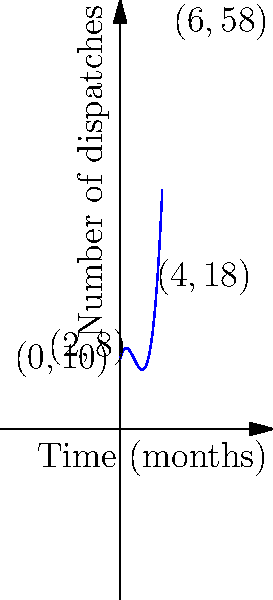The cubic polynomial graph represents the number of foreign correspondent dispatches during the first 6 months of the Spanish Civil War. If $f(x) = 0.5x^3 - 3x^2 + 4x + 10$, where $x$ represents the number of months since the war began and $f(x)$ represents the number of dispatches, at what point during this period was the rate of change in dispatches increasing most rapidly? To find the point where the rate of change in dispatches was increasing most rapidly, we need to follow these steps:

1) The rate of change is represented by the first derivative: $f'(x) = 1.5x^2 - 6x + 4$

2) The rate of change of the rate of change (acceleration) is represented by the second derivative: $f''(x) = 3x - 6$

3) The point where the rate of change is increasing most rapidly is where the second derivative is at its maximum.

4) Since $f''(x)$ is a linear function, its maximum within the given interval [0,6] will be at one of the endpoints.

5) Calculate $f''(0)$ and $f''(6)$:
   $f''(0) = 3(0) - 6 = -6$
   $f''(6) = 3(6) - 6 = 12$

6) The maximum value is at $x = 6$, so the rate of change was increasing most rapidly at the 6-month mark.

7) To find the corresponding number of dispatches, calculate $f(6)$:
   $f(6) = 0.5(6^3) - 3(6^2) + 4(6) + 10 = 108 - 108 + 24 + 10 = 58$
Answer: (6, 58) 